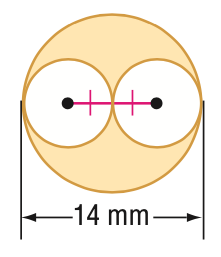Question: Find the area of the shaded region. Round to the nearest tenth.
Choices:
A. 38.5
B. 77.0
C. 115.5
D. 153.9
Answer with the letter. Answer: B 